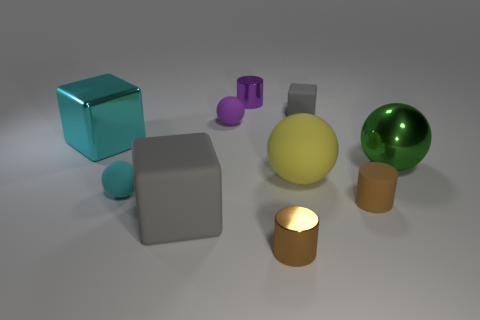Subtract all cylinders. How many objects are left? 7 Add 9 cyan shiny objects. How many cyan shiny objects are left? 10 Add 4 yellow shiny balls. How many yellow shiny balls exist? 4 Subtract 0 blue balls. How many objects are left? 10 Subtract all tiny balls. Subtract all small gray matte cubes. How many objects are left? 7 